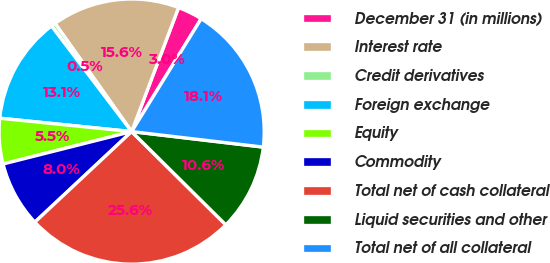Convert chart to OTSL. <chart><loc_0><loc_0><loc_500><loc_500><pie_chart><fcel>December 31 (in millions)<fcel>Interest rate<fcel>Credit derivatives<fcel>Foreign exchange<fcel>Equity<fcel>Commodity<fcel>Total net of cash collateral<fcel>Liquid securities and other<fcel>Total net of all collateral<nl><fcel>3.03%<fcel>15.57%<fcel>0.52%<fcel>13.06%<fcel>5.54%<fcel>8.04%<fcel>25.61%<fcel>10.55%<fcel>18.08%<nl></chart> 